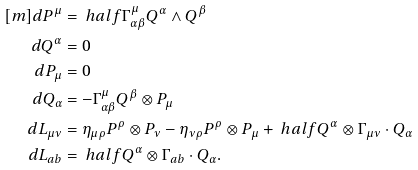Convert formula to latex. <formula><loc_0><loc_0><loc_500><loc_500>[ m ] d P ^ { \mu } & = \ h a l f \Gamma ^ { \mu } _ { \alpha \beta } Q ^ { \alpha } \wedge Q ^ { \beta } \\ d Q ^ { \alpha } & = 0 \\ d P _ { \mu } & = 0 \\ d Q _ { \alpha } & = - \Gamma ^ { \mu } _ { \alpha \beta } Q ^ { \beta } \otimes P _ { \mu } \\ d L _ { \mu \nu } & = \eta _ { \mu \rho } P ^ { \rho } \otimes P _ { \nu } - \eta _ { \nu \rho } P ^ { \rho } \otimes P _ { \mu } + \ h a l f Q ^ { \alpha } \otimes \Gamma _ { \mu \nu } \cdot Q _ { \alpha } \\ d L _ { a b } & = \ h a l f Q ^ { \alpha } \otimes \Gamma _ { a b } \cdot Q _ { \alpha } .</formula> 